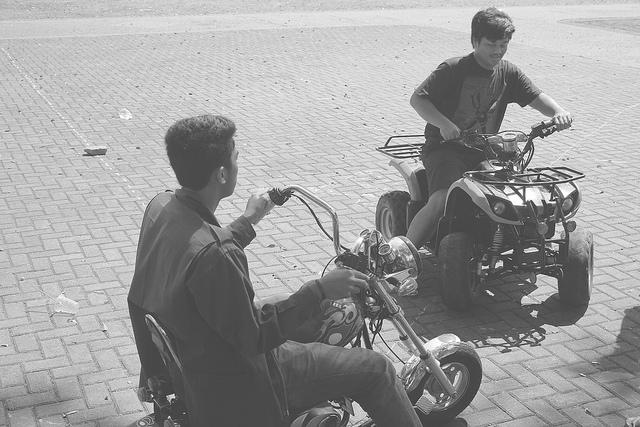Where are these men riding? atvs 